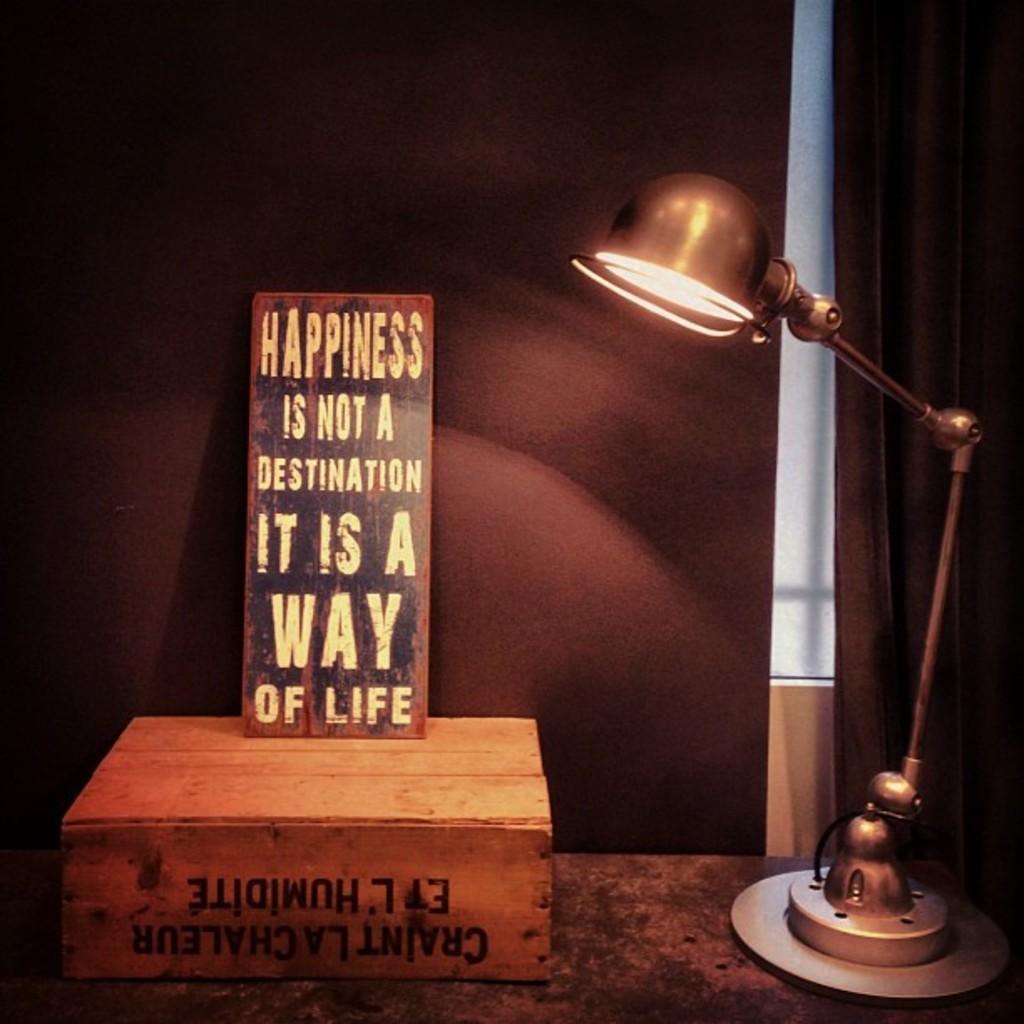In one or two sentences, can you explain what this image depicts? In this image there is a table at the bottom, on which there is a lamp, wooden box, on wooden box there is a text, on top of there is a text, behind the table there might be the wall. 